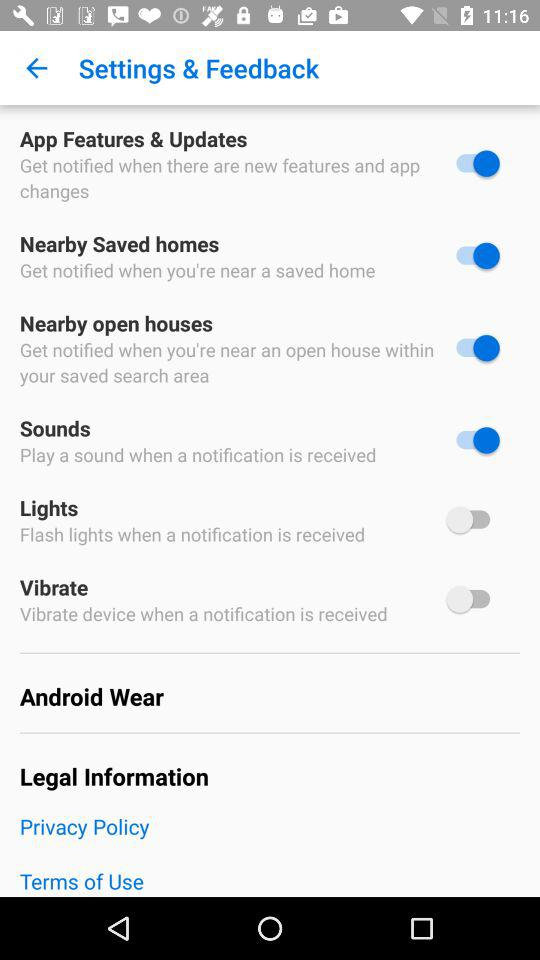Which options are disabled? The disabled options are "Lights" and "Vibrate". 